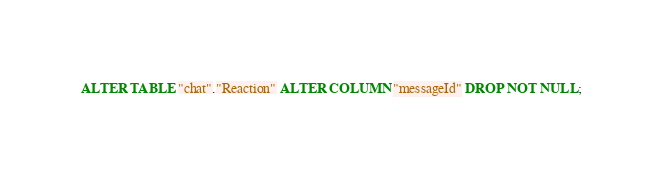Convert code to text. <code><loc_0><loc_0><loc_500><loc_500><_SQL_>ALTER TABLE "chat"."Reaction" ALTER COLUMN "messageId" DROP NOT NULL;
</code> 